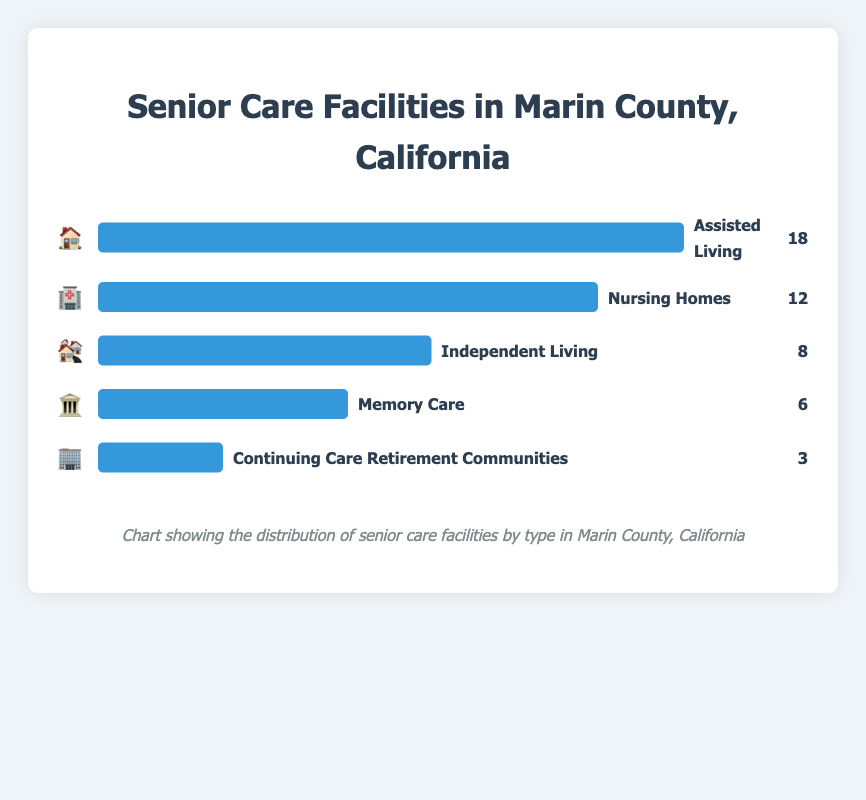What type of senior care facility has the highest count? Look at the bars in the chart and identify which bar is the longest. The "Assisted Living" facility bar is the longest, indicating it has the highest count.
Answer: Assisted Living How many Memory Care facilities are there? Find the bar labeled "Memory Care" and check the count associated with it.
Answer: 6 Which facility type has the fewest number of units? Find the shortest bar in the chart. The bar for "Continuing Care Retirement Communities" is the shortest, indicating it has the fewest number of units.
Answer: Continuing Care Retirement Communities Are there more Nursing Homes or Independent Living facilities? Compare the lengths and counts of the bars for "Nursing Homes" and "Independent Living". "Nursing Homes" has 12 facilities, while "Independent Living" has 8.
Answer: Nursing Homes What is the total number of senior care facilities represented in the chart? Add up the counts of all the different facility types: 18 (Assisted Living) + 12 (Nursing Homes) + 8 (Independent Living) + 6 (Memory Care) + 3 (Continuing Care Retirement Communities).
Answer: 47 How much larger is the number of Assisted Living facilities compared to Memory Care facilities? Subtract the number of Memory Care facilities from the number of Assisted Living facilities: 18 - 6.
Answer: 12 Which senior care facility type is represented by the 🏘️ emoji? Look at the emoji next to each bar. The 🏘️ emoji corresponds to "Independent Living".
Answer: Independent Living What is the combined count of Nursing Homes and Memory Care facilities? Add the counts of Nursing Homes and Memory Care facilities: 12 (Nursing Homes) + 6 (Memory Care).
Answer: 18 Are Independent Living facilities more common than Memory Care facilities? Compare the counts of Independent Living and Memory Care facilities. Independent Living has 8, and Memory Care has 6.
Answer: Yes By what percentage is the number of Assisted Living facilities greater than Continuing Care Retirement Communities? Calculate the percentage increase using the formula ((New Value - Old Value) / Old Value) * 100. That is ((18 - 3) / 3) * 100.
Answer: 500% 